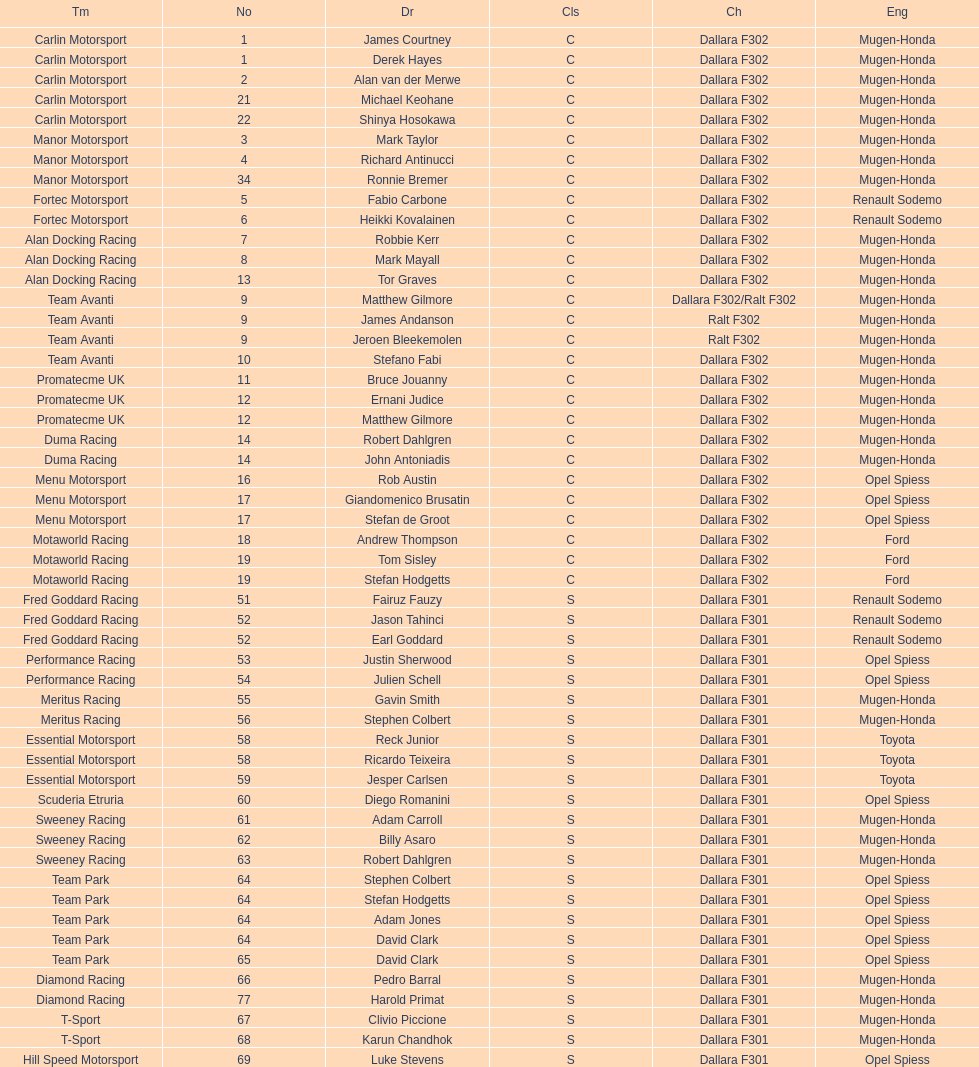What is the average number of teams that had a mugen-honda engine? 24. 